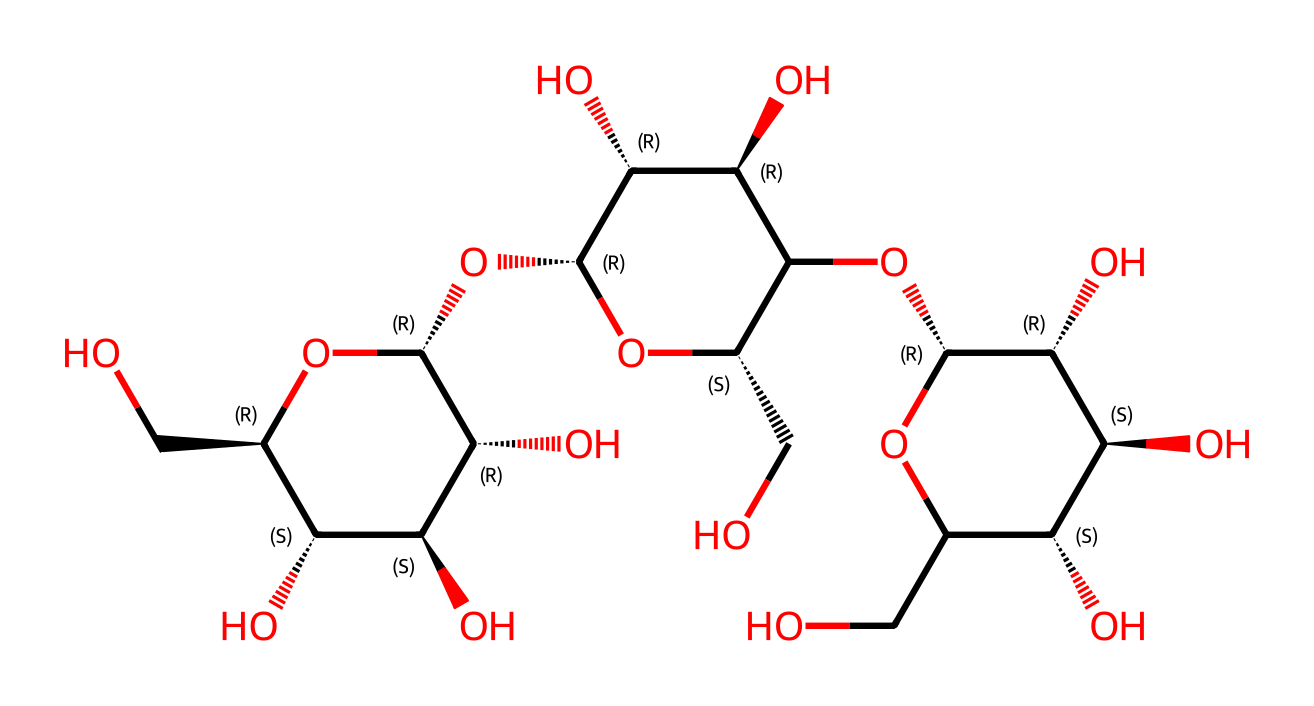What is the main component of this chemical structure? The chemical structure primarily consists of repeating units that form the polysaccharide known as cellulose, which is evident from its characteristic multiple hydroxyl (OH) groups and long-chain structure.
Answer: cellulose How many carbon atoms are in the structure? By examining the structure, I can count the number of carbon (C) atoms represented in the SMILES notation. In this case, there are 6 carbon atoms directly linked within each glucose repeating unit of cellulose. Counting these units gives a total of around 12 carbon atoms in the whole structure.
Answer: 12 How many hydroxyl (OH) groups are present in the structure? The structure displays numerous hydroxyl (OH) groups attached to the carbon backbone, which are notable for their role in hydrogen bonding and cellulose's hydrophilicity. Counting these OH groups shows there are approximately 10 hydroxyl groups present.
Answer: 10 What is the stereochemistry around the anomeric carbon? In the structure, the stereochemical configuration of the anomeric carbon can be analyzed. The presence of both [C@H] and [C@@H] notations indicates that there are two stereogenic centers, leading to a specific configuration at the anomeric carbon, which typically is in the beta form for cellulose.
Answer: beta What characteristic feature of cellulose allows it to form strong fiber structures? One of the key features allowing cellulose to form strong fiber structures is the presence of extensive hydrogen bonding due to the multiple hydroxyl (OH) groups, which facilitate intermolecular hydrogen bonds between adjacent cellulose chains, contributing to the fiber's strength and rigidity.
Answer: hydrogen bonding What type of linkages are present in cellulose fibers? Cellulose is characterized by beta-1,4-glycosidic linkages between its glucose units, which contribute to the linear structure that is fundamental to its fibrous nature. This specific linkage type is crucial for the structural integrity of cellulose fibers.
Answer: beta-1,4-glycosidic linkages 